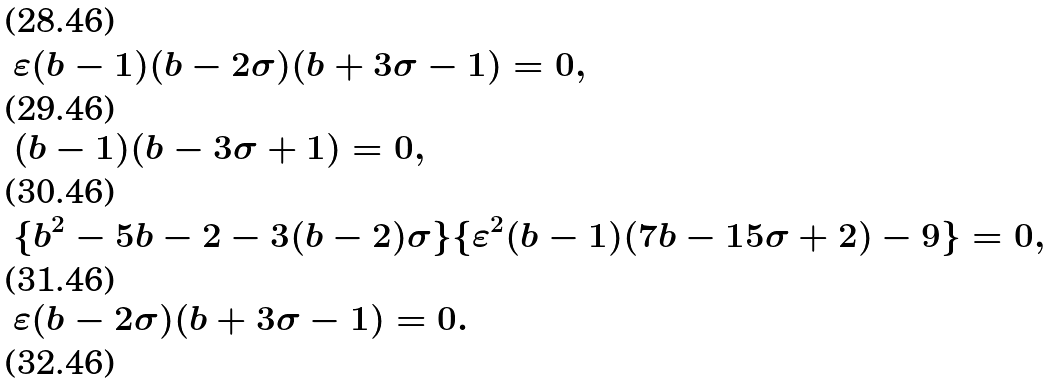<formula> <loc_0><loc_0><loc_500><loc_500>& \varepsilon ( b - 1 ) ( b - 2 \sigma ) ( b + 3 \sigma - 1 ) = 0 , \\ & ( b - 1 ) ( b - 3 \sigma + 1 ) = 0 , \\ & \{ b ^ { 2 } - 5 b - 2 - 3 ( b - 2 ) \sigma \} \{ \varepsilon ^ { 2 } ( b - 1 ) ( 7 b - 1 5 \sigma + 2 ) - 9 \} = 0 , \\ & \varepsilon ( b - 2 \sigma ) ( b + 3 \sigma - 1 ) = 0 . \\</formula> 